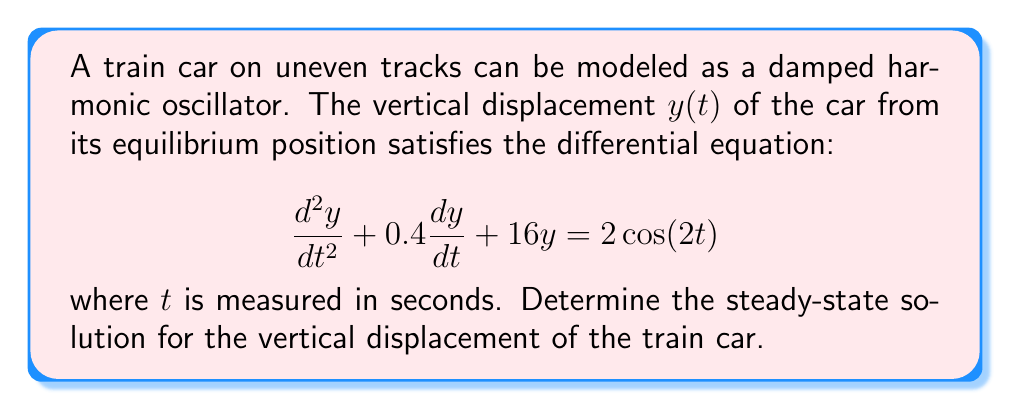Can you solve this math problem? To find the steady-state solution, we follow these steps:

1) The general form of the steady-state solution for a forced oscillation with cosine forcing is:

   $y_{ss}(t) = A\cos(2t) + B\sin(2t)$

2) We substitute this into the original differential equation:

   $\frac{d^2y_{ss}}{dt^2} + 0.4\frac{dy_{ss}}{dt} + 16y_{ss} = 2\cos(2t)$

3) Calculate the derivatives:
   
   $\frac{dy_{ss}}{dt} = -2A\sin(2t) + 2B\cos(2t)$
   
   $\frac{d^2y_{ss}}{dt^2} = -4A\cos(2t) - 4B\sin(2t)$

4) Substitute these into the left side of the equation:

   $(-4A\cos(2t) - 4B\sin(2t)) + 0.4(-2A\sin(2t) + 2B\cos(2t)) + 16(A\cos(2t) + B\sin(2t)) = 2\cos(2t)$

5) Collect terms:

   $(16A - 4A + 0.8B)\cos(2t) + (16B - 4B - 0.8A)\sin(2t) = 2\cos(2t)$

   $(12A + 0.8B)\cos(2t) + (12B - 0.8A)\sin(2t) = 2\cos(2t)$

6) Equate coefficients:

   $12A + 0.8B = 2$
   $12B - 0.8A = 0$

7) Solve this system of equations:
   
   From the second equation: $B = \frac{0.8A}{12} = \frac{A}{15}$
   
   Substitute into the first equation:
   
   $12A + 0.8(\frac{A}{15}) = 2$
   
   $12A + \frac{0.8A}{15} = 2$
   
   $180A + 0.8A = 30$
   
   $180.8A = 30$
   
   $A = \frac{30}{180.8} \approx 0.1659$
   
   $B = \frac{A}{15} \approx 0.0111$

Therefore, the steady-state solution is:

$y_{ss}(t) \approx 0.1659\cos(2t) + 0.0111\sin(2t)$
Answer: $y_{ss}(t) \approx 0.1659\cos(2t) + 0.0111\sin(2t)$ 